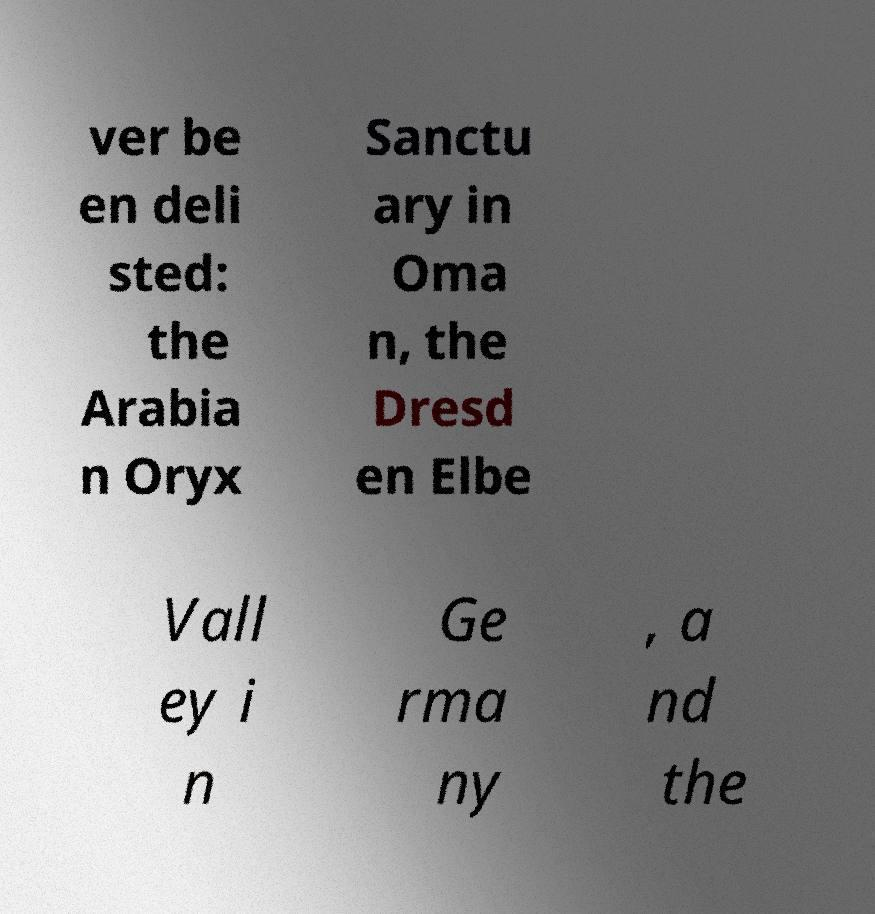Please read and relay the text visible in this image. What does it say? ver be en deli sted: the Arabia n Oryx Sanctu ary in Oma n, the Dresd en Elbe Vall ey i n Ge rma ny , a nd the 